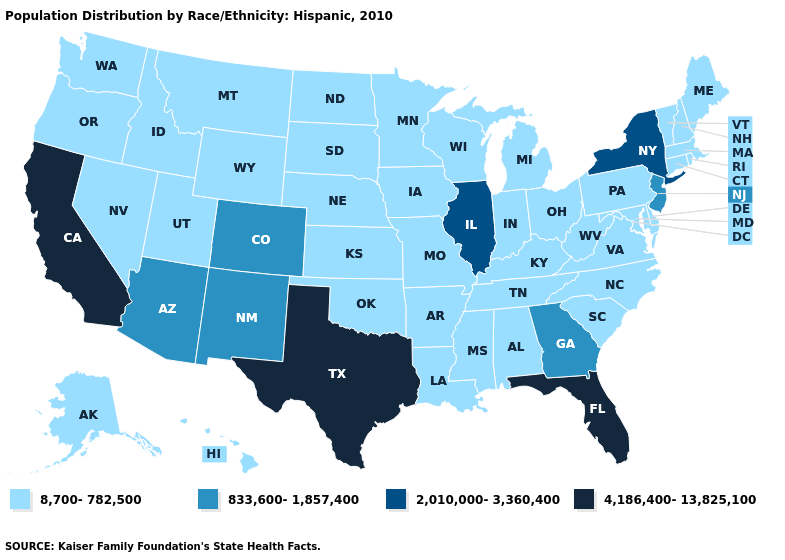What is the value of Louisiana?
Short answer required. 8,700-782,500. What is the highest value in the West ?
Answer briefly. 4,186,400-13,825,100. Name the states that have a value in the range 4,186,400-13,825,100?
Answer briefly. California, Florida, Texas. What is the lowest value in the USA?
Write a very short answer. 8,700-782,500. What is the value of Alaska?
Write a very short answer. 8,700-782,500. Does the first symbol in the legend represent the smallest category?
Keep it brief. Yes. Name the states that have a value in the range 8,700-782,500?
Short answer required. Alabama, Alaska, Arkansas, Connecticut, Delaware, Hawaii, Idaho, Indiana, Iowa, Kansas, Kentucky, Louisiana, Maine, Maryland, Massachusetts, Michigan, Minnesota, Mississippi, Missouri, Montana, Nebraska, Nevada, New Hampshire, North Carolina, North Dakota, Ohio, Oklahoma, Oregon, Pennsylvania, Rhode Island, South Carolina, South Dakota, Tennessee, Utah, Vermont, Virginia, Washington, West Virginia, Wisconsin, Wyoming. Name the states that have a value in the range 8,700-782,500?
Keep it brief. Alabama, Alaska, Arkansas, Connecticut, Delaware, Hawaii, Idaho, Indiana, Iowa, Kansas, Kentucky, Louisiana, Maine, Maryland, Massachusetts, Michigan, Minnesota, Mississippi, Missouri, Montana, Nebraska, Nevada, New Hampshire, North Carolina, North Dakota, Ohio, Oklahoma, Oregon, Pennsylvania, Rhode Island, South Carolina, South Dakota, Tennessee, Utah, Vermont, Virginia, Washington, West Virginia, Wisconsin, Wyoming. What is the highest value in the USA?
Quick response, please. 4,186,400-13,825,100. Does Florida have the highest value in the South?
Concise answer only. Yes. Among the states that border Wyoming , which have the highest value?
Short answer required. Colorado. Does South Carolina have a higher value than Virginia?
Answer briefly. No. What is the highest value in states that border Maine?
Be succinct. 8,700-782,500. What is the lowest value in the USA?
Concise answer only. 8,700-782,500. Is the legend a continuous bar?
Concise answer only. No. 